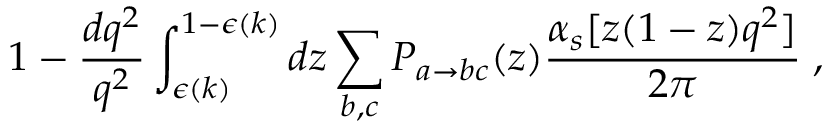Convert formula to latex. <formula><loc_0><loc_0><loc_500><loc_500>1 - \frac { d q ^ { 2 } } { q ^ { 2 } } \int _ { \epsilon ( k ) } ^ { 1 - \epsilon ( k ) } d z \sum _ { b , c } P _ { a \rightarrow b c } ( z ) \frac { \alpha _ { s } [ z ( 1 - z ) q ^ { 2 } ] } { 2 \pi } \, ,</formula> 